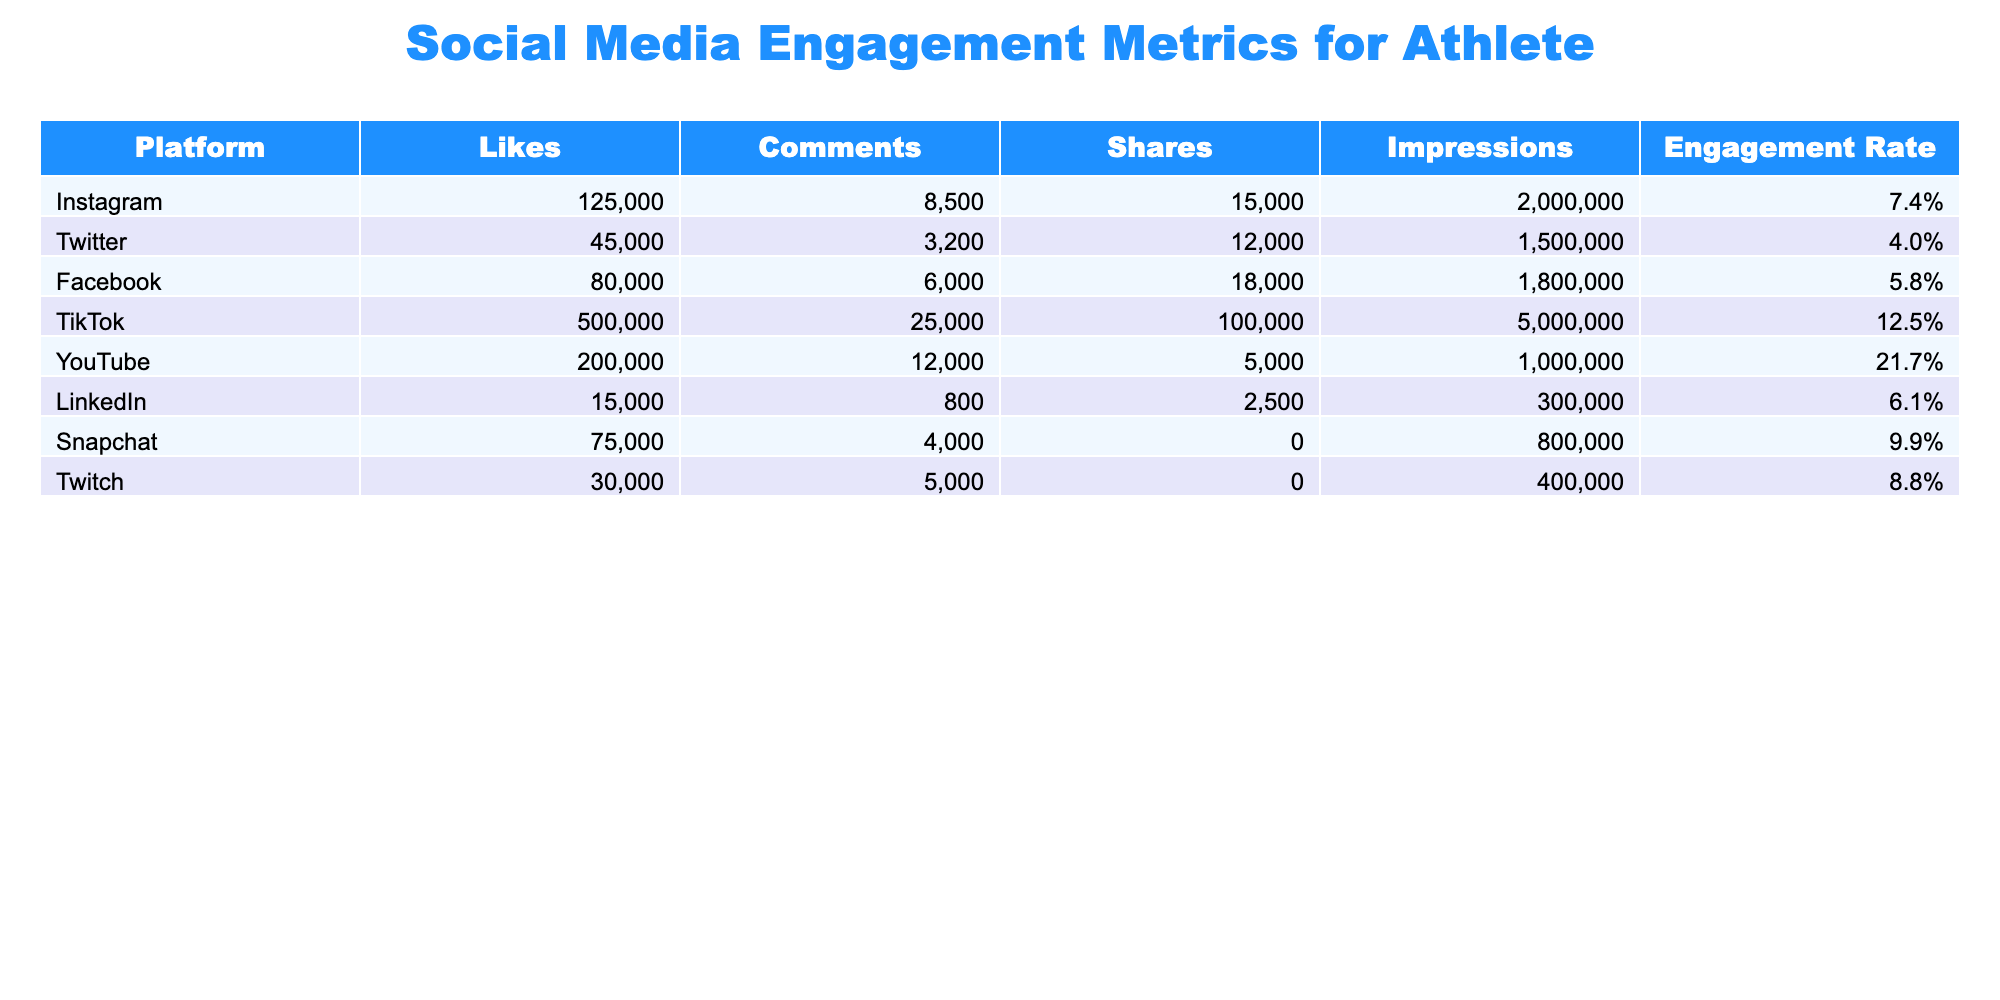What platform has the highest engagement rate? By comparing the engagement rates listed for each platform, TikTok has the highest engagement rate at 12.5%.
Answer: TikTok How many likes did the YouTube posts receive? The table states that YouTube received 200,000 likes for their posts.
Answer: 200,000 Which platform had the lowest number of shares? The data shows that LinkedIn has the lowest number of shares, with only 2,500 shares.
Answer: LinkedIn What is the total number of comments across all platforms? To find the total comments, sum the comments from each platform: 8500 + 3200 + 6000 + 25000 + 12000 + 800 + 4000 + 5000 = 57,500.
Answer: 57,500 Is the engagement rate for Facebook greater than that for Twitter? Facebook has an engagement rate of 5.8% while Twitter has a rate of 4.0%, which confirms that Facebook's rate is indeed greater than Twitter's.
Answer: Yes Which platform has more impressions, Instagram or Snapchat? Instagram has 2,000,000 impressions while Snapchat has 800,000 impressions. Therefore, Instagram has more impressions than Snapchat.
Answer: Instagram What is the average number of shares for all platforms? Calculate the total shares: 15,000 + 12,000 + 18,000 + 100,000 + 5,000 + 2,500 + N/A + N/A; excluding N/A gives 152,500. There are 6 valid platforms, so 152,500 / 6 = 25,417 (rounded).
Answer: 25,417 Are TikTok posts more engaging than YouTube posts when comparing engagement rates? TikTok has a rate of 12.5% while YouTube has a rate of 21.7%. Given these figures, YouTube posts are more engaging than TikTok posts, despite TikTok having larger absolute numbers.
Answer: No What is the difference in the number of likes between TikTok and Facebook? TikTok has 500,000 likes while Facebook has 80,000 likes. The difference is 500,000 - 80,000 = 420,000 likes.
Answer: 420,000 Which platform has the highest number of impressions and what is that value? The table shows TikTok has the highest number of impressions at 5,000,000 compared to all other platforms.
Answer: TikTok, 5,000,000 